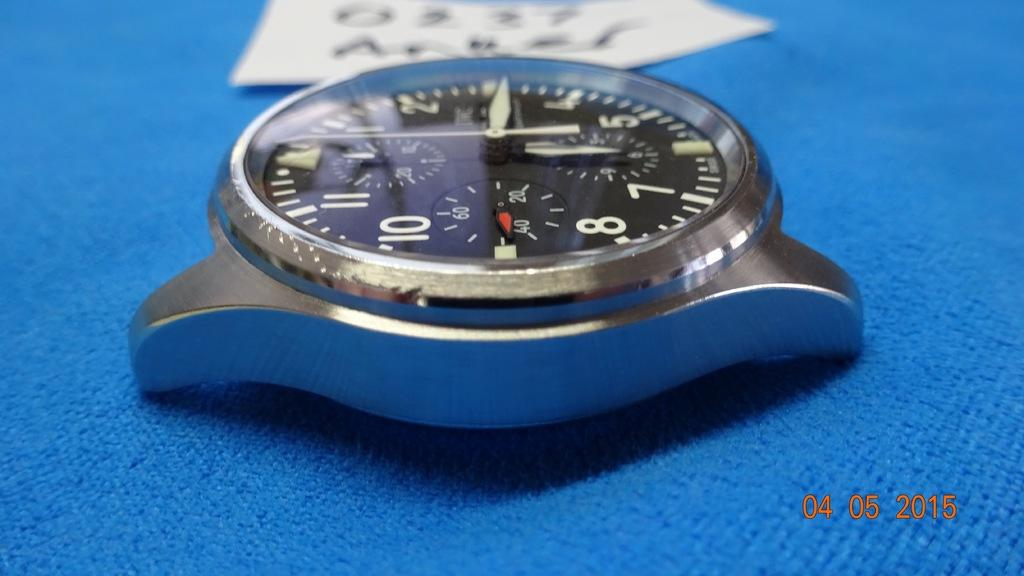Provide a one-sentence caption for the provided image. A watch displaying that the time is 6:15. 